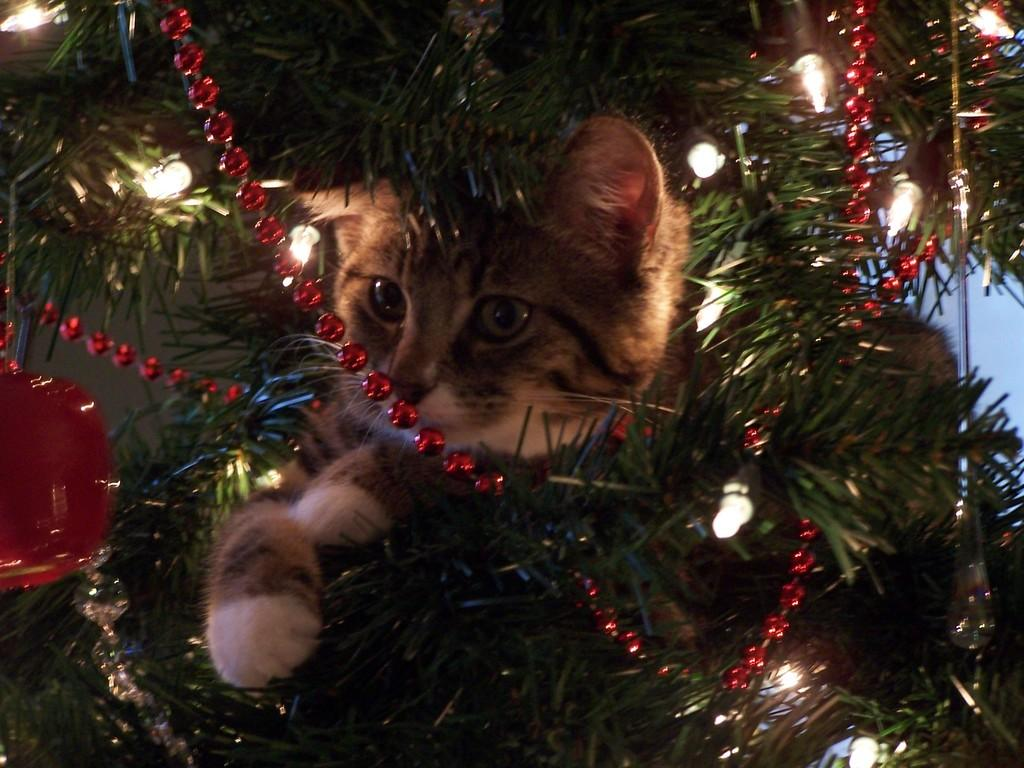What is the main subject in the foreground of the image? There is a cat in the foreground of the image. Where is the cat located? The cat is in a Christmas tree. What can be seen on the Christmas tree besides the cat? There are lights and decorations on the Christmas tree. What type of cemetery can be seen in the background of the image? There is no cemetery present in the image; it features a cat in a Christmas tree. How does the cat control the lights on the Christmas tree? The cat does not control the lights on the Christmas tree; the lights are likely controlled by a switch or timer. 